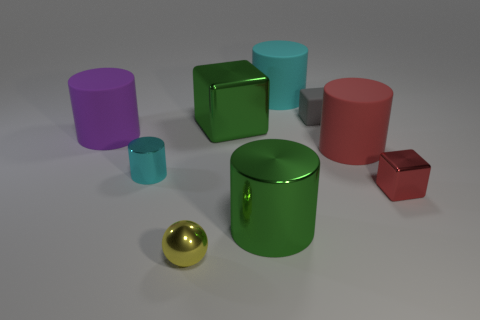Is there a thing that has the same color as the large block?
Make the answer very short. Yes. The thing that is the same color as the tiny cylinder is what shape?
Offer a very short reply. Cylinder. What is the color of the large object that is the same shape as the tiny gray thing?
Your answer should be very brief. Green. Do the block that is right of the tiny rubber thing and the yellow object have the same material?
Ensure brevity in your answer.  Yes. How many small things are metallic cubes or red cubes?
Your answer should be compact. 1. What is the size of the red matte object?
Offer a terse response. Large. There is a red cylinder; is it the same size as the green metal object to the right of the big green metal cube?
Provide a short and direct response. Yes. What number of brown objects are either big blocks or large objects?
Make the answer very short. 0. How many tiny rubber objects are there?
Give a very brief answer. 1. How big is the cyan cylinder in front of the tiny gray block?
Keep it short and to the point. Small. 